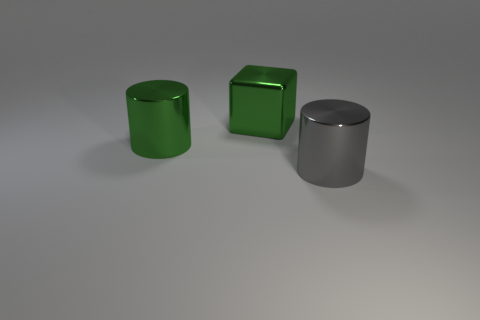What size is the cylinder that is the same color as the large shiny block?
Ensure brevity in your answer.  Large. There is a big metal object that is to the left of the shiny cube; does it have the same color as the big metal cube?
Your response must be concise. Yes. Is there a large metal cylinder of the same color as the large cube?
Your response must be concise. Yes. Is there a big gray rubber cylinder?
Make the answer very short. No. Is the size of the cylinder that is left of the gray shiny cylinder the same as the gray metallic object?
Your response must be concise. Yes. Are there fewer large gray metallic things than small cyan matte objects?
Offer a very short reply. No. What is the shape of the large green metal object in front of the big green metallic object behind the green metal cylinder in front of the cube?
Offer a terse response. Cylinder. Are there any big green things that have the same material as the large gray thing?
Offer a very short reply. Yes. There is a thing left of the green cube; is it the same color as the cube that is to the left of the large gray cylinder?
Your answer should be very brief. Yes. Is the number of large green metallic objects that are right of the metallic block less than the number of gray metal cylinders?
Your answer should be very brief. Yes. 